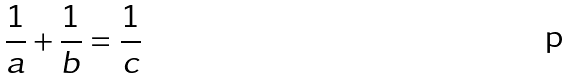<formula> <loc_0><loc_0><loc_500><loc_500>\frac { 1 } { a } + \frac { 1 } { b } = \frac { 1 } { c }</formula> 